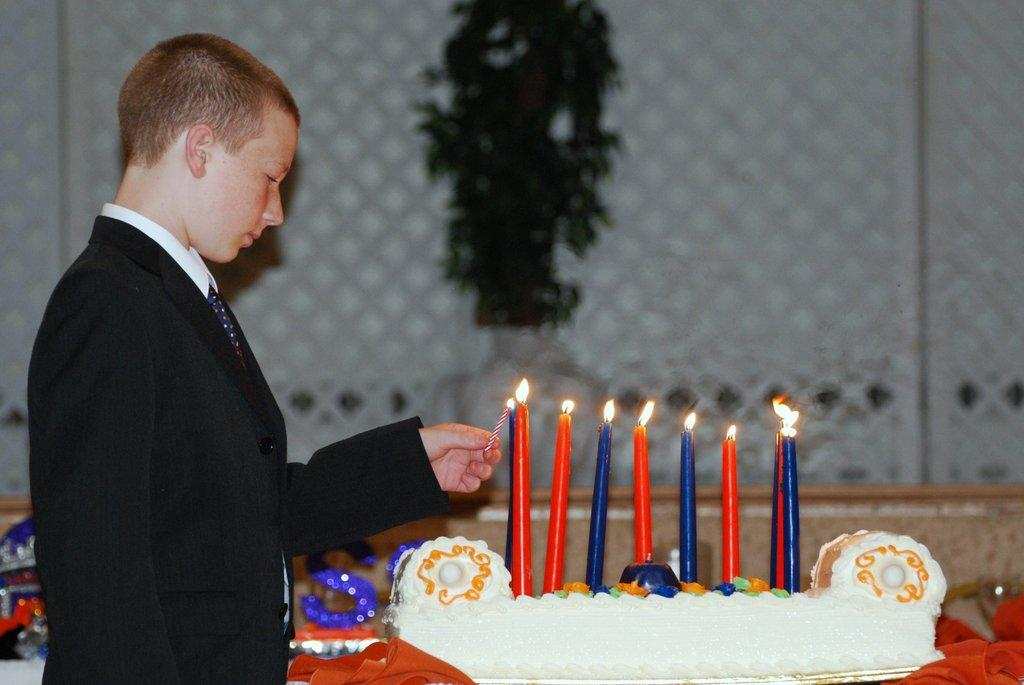What is the person holding in the image? The person is holding a candle in the image. What else can be seen in the image besides the person holding the candle? There is a cake in the image, and candles are on the cake. What is visible in the background of the image? There are objects visible in the background of the image, but their specific details are not clear due to the blurred appearance. What type of coast can be seen in the background of the image? There is no coast visible in the image; the background appears blurred, but no specific geographical features can be identified. 